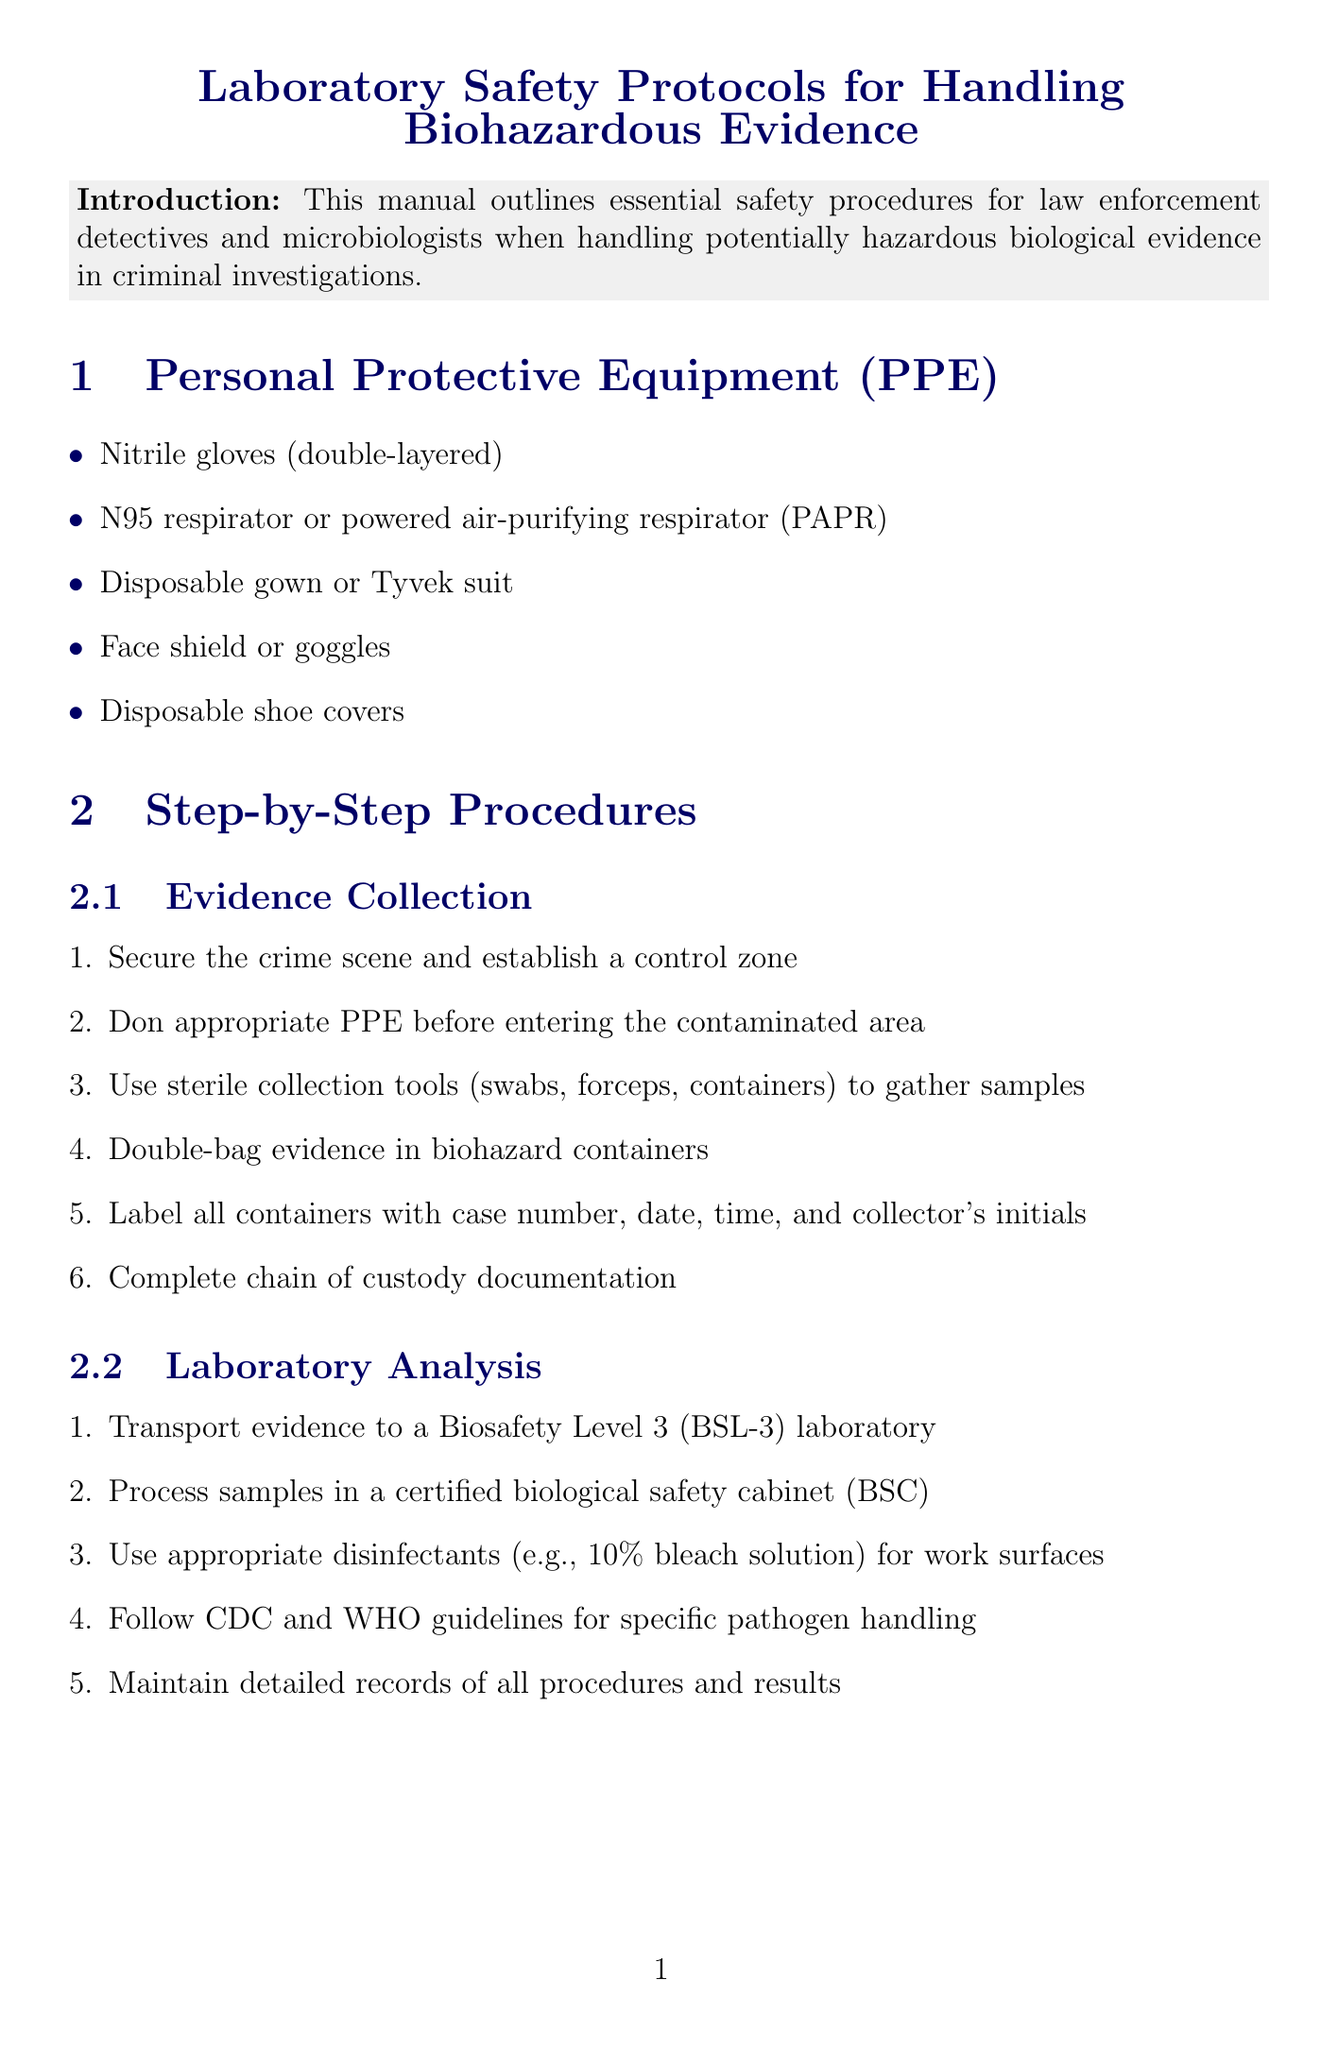What are the PPE requirements? The document lists the specific personal protective equipment required when handling biohazardous evidence.
Answer: Nitrile gloves, N95 respirator, disposable gown, face shield, shoe covers How many steps are there in evidence collection? The section on evidence collection outlines a sequence of steps required for the safe collection of evidence.
Answer: Six steps What disinfectant is recommended for work surfaces? The laboratory analysis section advises on disinfectants to use, highlighting specific types effective against pathogens.
Answer: 10% bleach solution What is one method of decontamination mentioned? The document outlines various decontamination methods for handling biohazardous materials.
Answer: Chemical disinfection Which agency should be reported to in case of an incident? The emergency procedures section specifies authorities to inform regarding incident responses.
Answer: CDC Why is it important to document procedures? The documentation and reporting section emphasizes the significance of maintaining records in laboratory practices.
Answer: To maintain integrity and support investigations What is the temperature setting for autoclave sterilization? The decontamination methods provide a specific protocol for sterilization and the conditions required.
Answer: 121°C What is the primary purpose of this manual? The introduction clarifies the manual's objective concerning safety in handling biohazardous evidence.
Answer: Safety procedures 